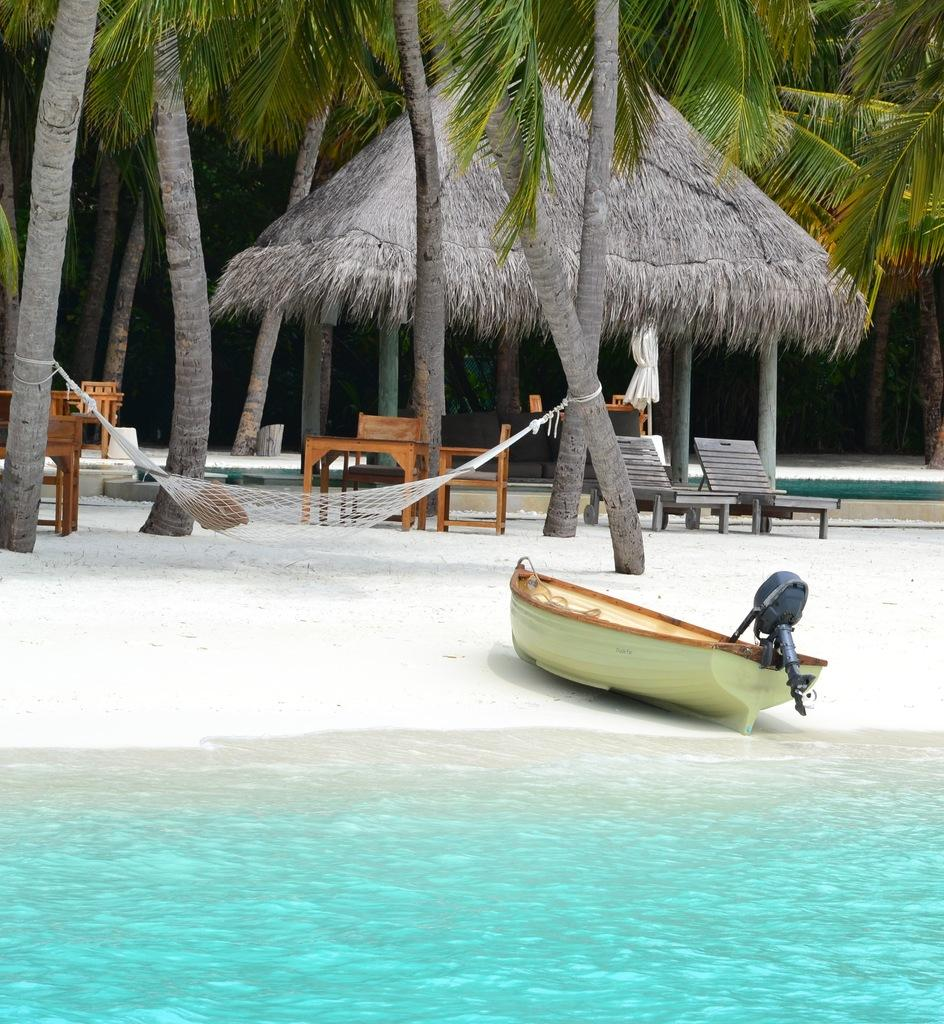What is the main subject of the image? The main subject of the image is a boat. What can be seen in the background of the image? There is water visible in the image. What other objects or structures are present in the image? There is a jet, tables and chairs, a hut, and trees in the image. What type of fan can be seen in the image? There is no fan present in the image. Can you hear the rhythm of the owl's wings flapping in the image? There is no owl present in the image, so it is not possible to hear the rhythm of its wings flapping. 